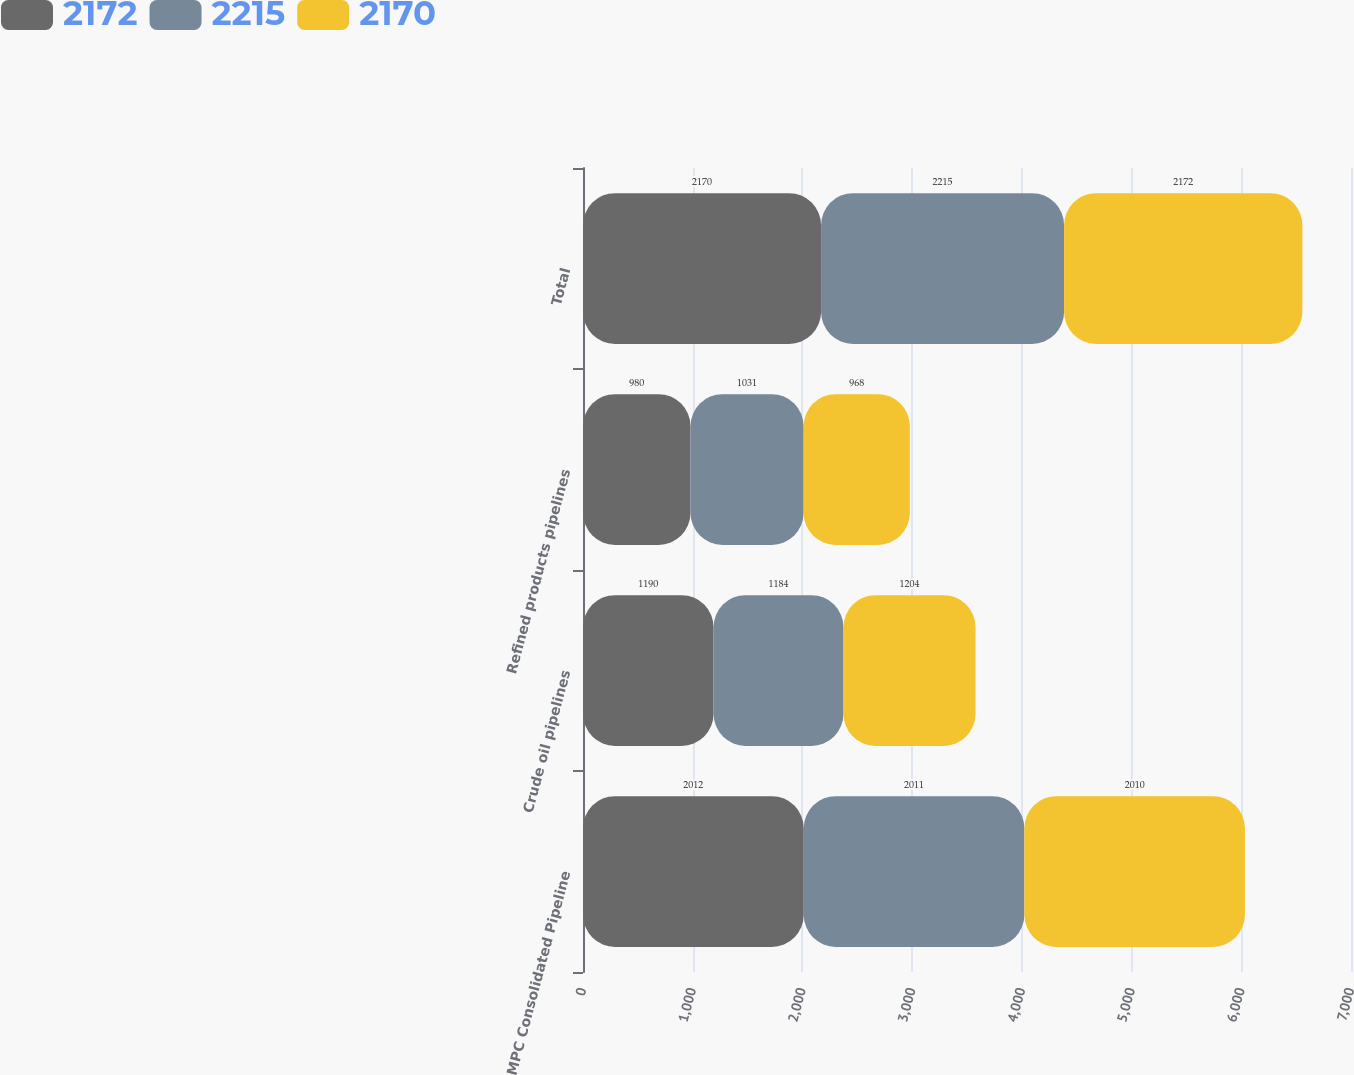Convert chart to OTSL. <chart><loc_0><loc_0><loc_500><loc_500><stacked_bar_chart><ecel><fcel>MPC Consolidated Pipeline<fcel>Crude oil pipelines<fcel>Refined products pipelines<fcel>Total<nl><fcel>2172<fcel>2012<fcel>1190<fcel>980<fcel>2170<nl><fcel>2215<fcel>2011<fcel>1184<fcel>1031<fcel>2215<nl><fcel>2170<fcel>2010<fcel>1204<fcel>968<fcel>2172<nl></chart> 